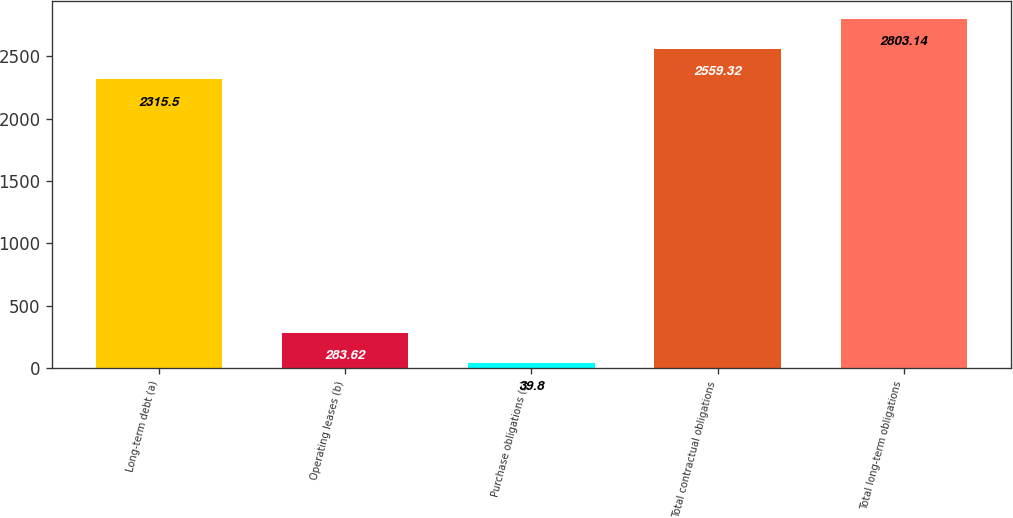Convert chart to OTSL. <chart><loc_0><loc_0><loc_500><loc_500><bar_chart><fcel>Long-term debt (a)<fcel>Operating leases (b)<fcel>Purchase obligations (c)<fcel>Total contractual obligations<fcel>Total long-term obligations<nl><fcel>2315.5<fcel>283.62<fcel>39.8<fcel>2559.32<fcel>2803.14<nl></chart> 